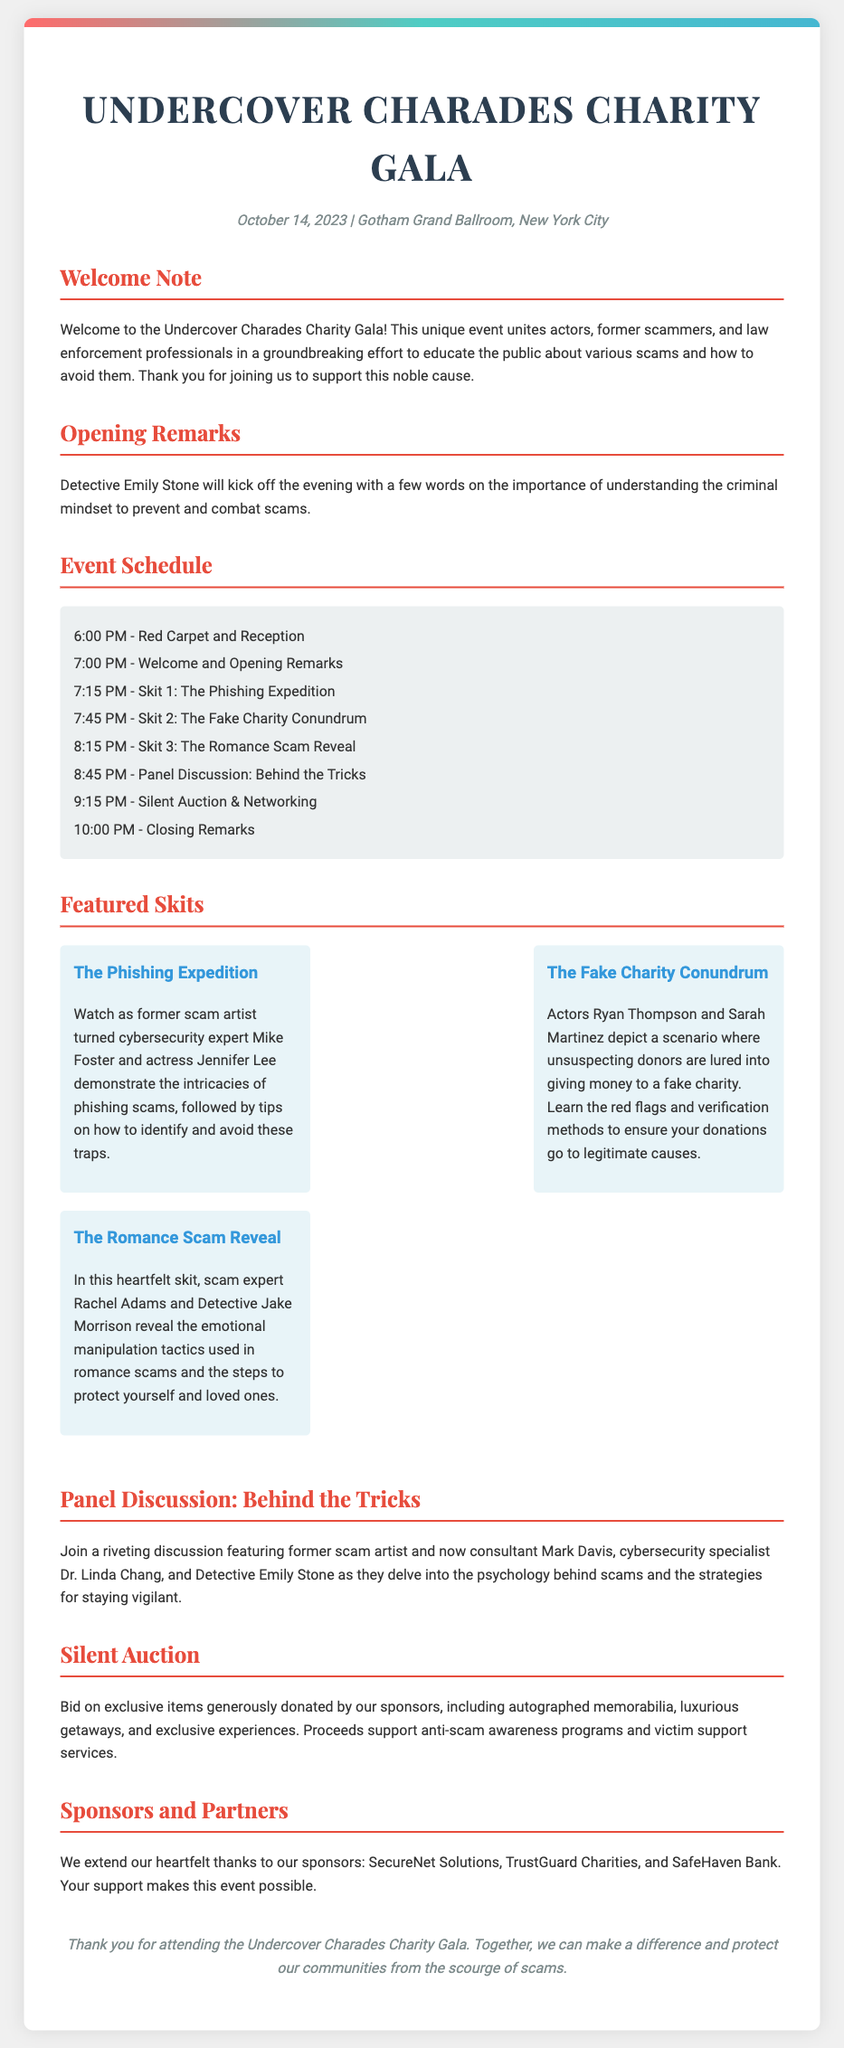What is the event date? The event date is listed prominently in the document as October 14, 2023.
Answer: October 14, 2023 Who will give the opening remarks? The document specifies Detective Emily Stone will give the opening remarks at the event.
Answer: Detective Emily Stone What is the name of the first skit? The first skit is titled "The Phishing Expedition," as shown in the schedule section.
Answer: The Phishing Expedition How long is the panel discussion scheduled for? The document indicates that the panel discussion occurs after skit three and before the silent auction, allowing for some estimation of duration.
Answer: 30 minutes What is being auctioned at the event? The document mentions that exclusive items will be up for bid during the silent auction, including memorabilia and getaways.
Answer: Exclusive items Which organization is thanked as a sponsor? The document lists several sponsors, including SecureNet Solutions as one of the sponsors.
Answer: SecureNet Solutions What is the purpose of the gala? The main purpose of the gala is to educate the public on scams and support anti-scam awareness programs.
Answer: Educate the public about scams What type of professionals are participating in the event? The participants include law enforcement professionals and scam experts, highlighting a diverse set of skills and perspectives.
Answer: Law enforcement professionals and scam experts What is the location of the gala? The gala is set to take place at Gotham Grand Ballroom in New York City, as indicated in the event details.
Answer: Gotham Grand Ballroom, New York City 